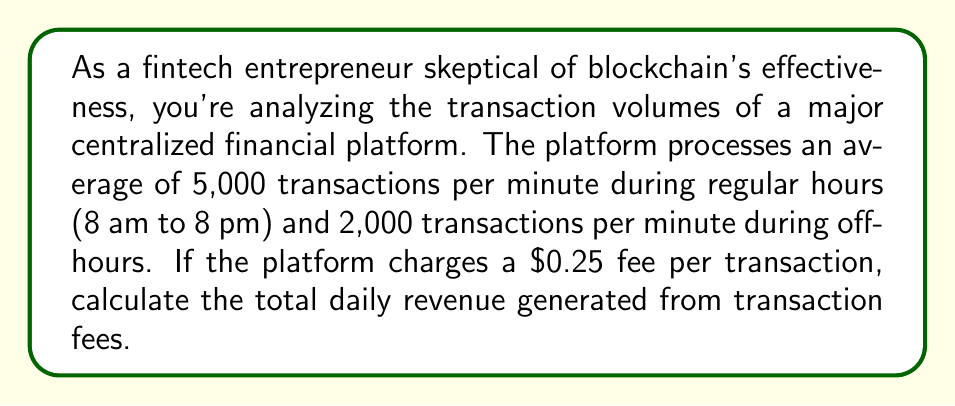Can you solve this math problem? To solve this problem, we'll follow these steps:

1. Calculate the number of transactions during regular hours:
   Regular hours: 8 am to 8 pm = 12 hours
   $$12 \text{ hours} \times 60 \text{ minutes/hour} \times 5,000 \text{ transactions/minute} = 3,600,000 \text{ transactions}$$

2. Calculate the number of transactions during off-hours:
   Off-hours: 12 hours (8 pm to 8 am)
   $$12 \text{ hours} \times 60 \text{ minutes/hour} \times 2,000 \text{ transactions/minute} = 1,440,000 \text{ transactions}$$

3. Calculate the total number of daily transactions:
   $$3,600,000 + 1,440,000 = 5,040,000 \text{ transactions}$$

4. Calculate the total daily revenue:
   $$5,040,000 \text{ transactions} \times \$0.25/\text{transaction} = \$1,260,000$$

Therefore, the total daily revenue generated from transaction fees is $1,260,000.
Answer: $1,260,000 